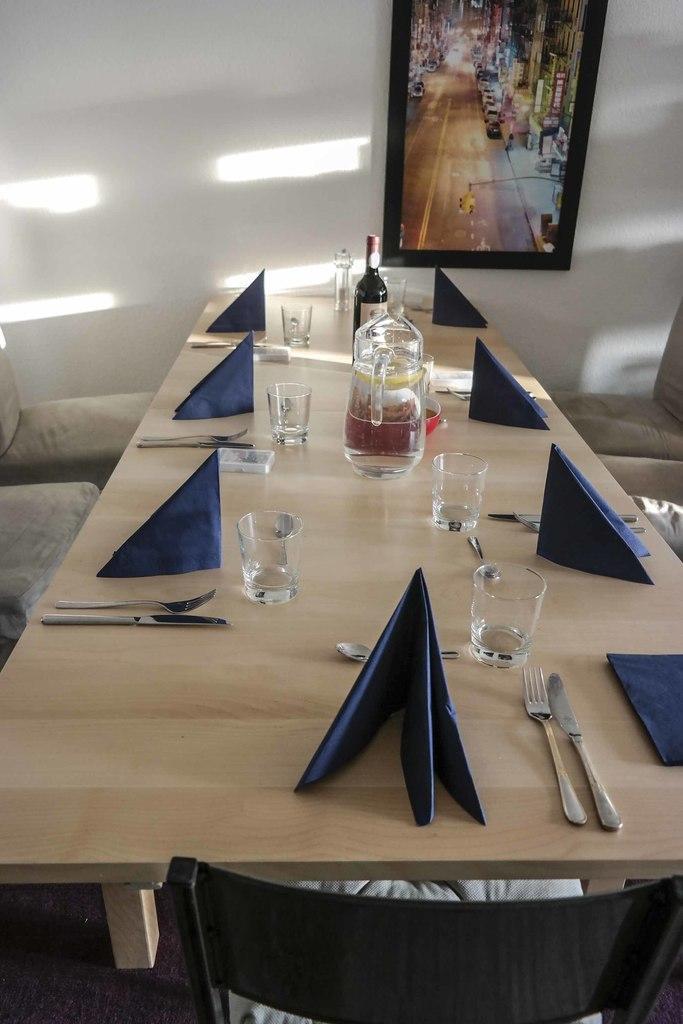In one or two sentences, can you explain what this image depicts? At the bottom of the image there is a chair. Behind the chair there is a table with glasses, forks, knives, clothes, jug with water, bottle and some other things on it. On the left and right side of the image there are chairs. In the background there is a wall with a frame. 